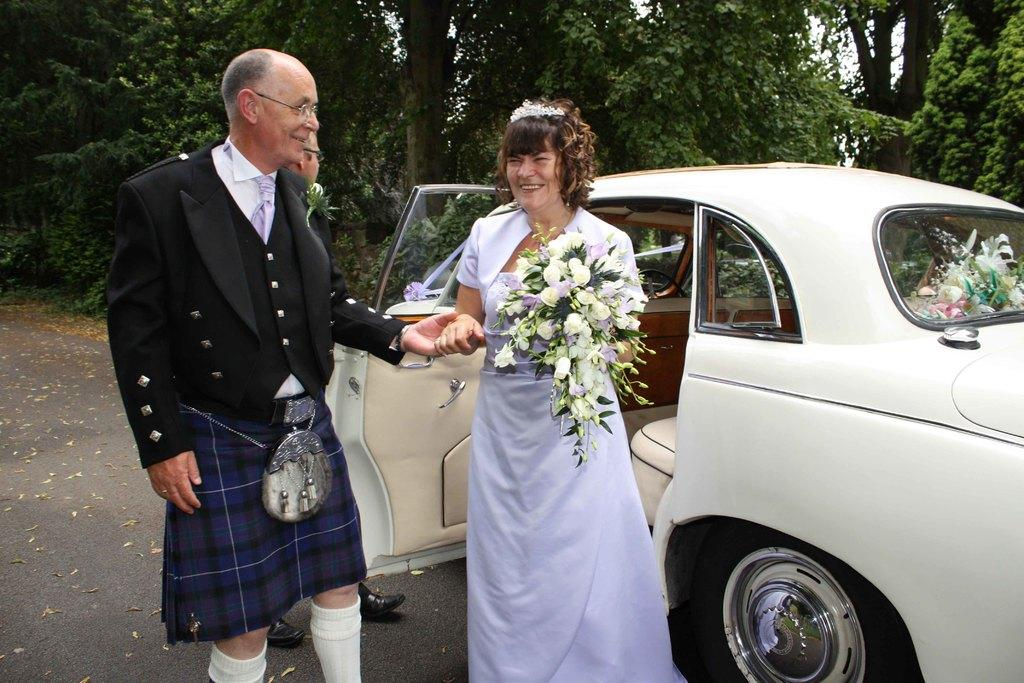How many people are standing on the left side of the image? There are two persons standing on the left side of the image. What is the woman in the middle of the image holding? The woman in the middle of the image is holding flowers. What can be seen in the background of the image? There is a car visible in the image, and there are trees present in the image. What type of rod can be seen erupting from the volcano in the image? There is no volcano present in the image, so there is no rod erupting from it. What idea does the woman in the image have for the upcoming event? The image does not provide any information about an upcoming event or the woman's ideas, so we cannot answer this question. 